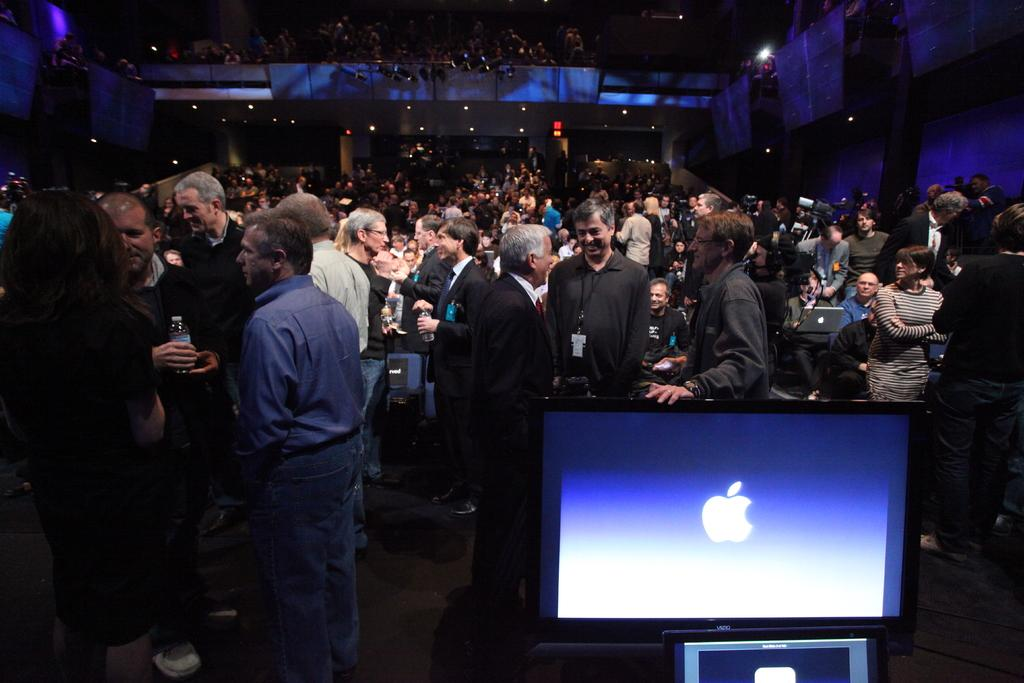What is the main object in the image? There is a monitor in the image. What can be seen in the background of the image? There are people standing and sitting on chairs in the background of the image. What type of cup is being used for observation in the image? There is no cup present in the image, and no observation is being conducted. 